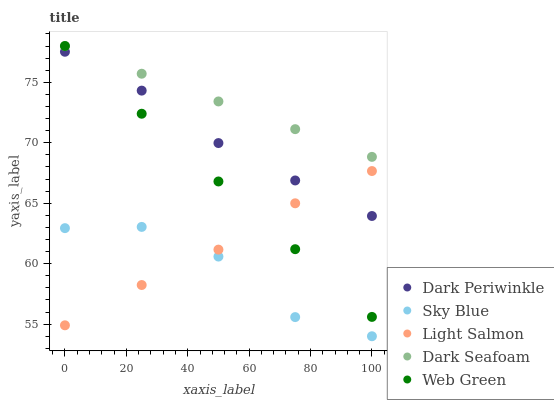Does Sky Blue have the minimum area under the curve?
Answer yes or no. Yes. Does Dark Seafoam have the maximum area under the curve?
Answer yes or no. Yes. Does Light Salmon have the minimum area under the curve?
Answer yes or no. No. Does Light Salmon have the maximum area under the curve?
Answer yes or no. No. Is Dark Seafoam the smoothest?
Answer yes or no. Yes. Is Sky Blue the roughest?
Answer yes or no. Yes. Is Light Salmon the smoothest?
Answer yes or no. No. Is Light Salmon the roughest?
Answer yes or no. No. Does Sky Blue have the lowest value?
Answer yes or no. Yes. Does Light Salmon have the lowest value?
Answer yes or no. No. Does Dark Seafoam have the highest value?
Answer yes or no. Yes. Does Light Salmon have the highest value?
Answer yes or no. No. Is Dark Periwinkle less than Dark Seafoam?
Answer yes or no. Yes. Is Dark Periwinkle greater than Sky Blue?
Answer yes or no. Yes. Does Dark Periwinkle intersect Web Green?
Answer yes or no. Yes. Is Dark Periwinkle less than Web Green?
Answer yes or no. No. Is Dark Periwinkle greater than Web Green?
Answer yes or no. No. Does Dark Periwinkle intersect Dark Seafoam?
Answer yes or no. No. 